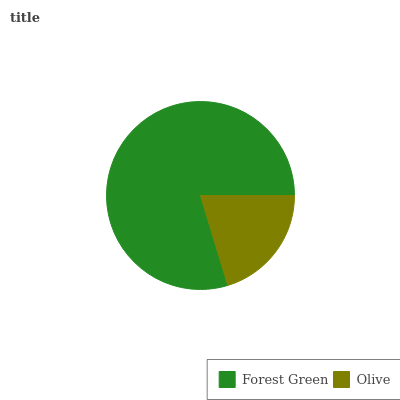Is Olive the minimum?
Answer yes or no. Yes. Is Forest Green the maximum?
Answer yes or no. Yes. Is Olive the maximum?
Answer yes or no. No. Is Forest Green greater than Olive?
Answer yes or no. Yes. Is Olive less than Forest Green?
Answer yes or no. Yes. Is Olive greater than Forest Green?
Answer yes or no. No. Is Forest Green less than Olive?
Answer yes or no. No. Is Forest Green the high median?
Answer yes or no. Yes. Is Olive the low median?
Answer yes or no. Yes. Is Olive the high median?
Answer yes or no. No. Is Forest Green the low median?
Answer yes or no. No. 